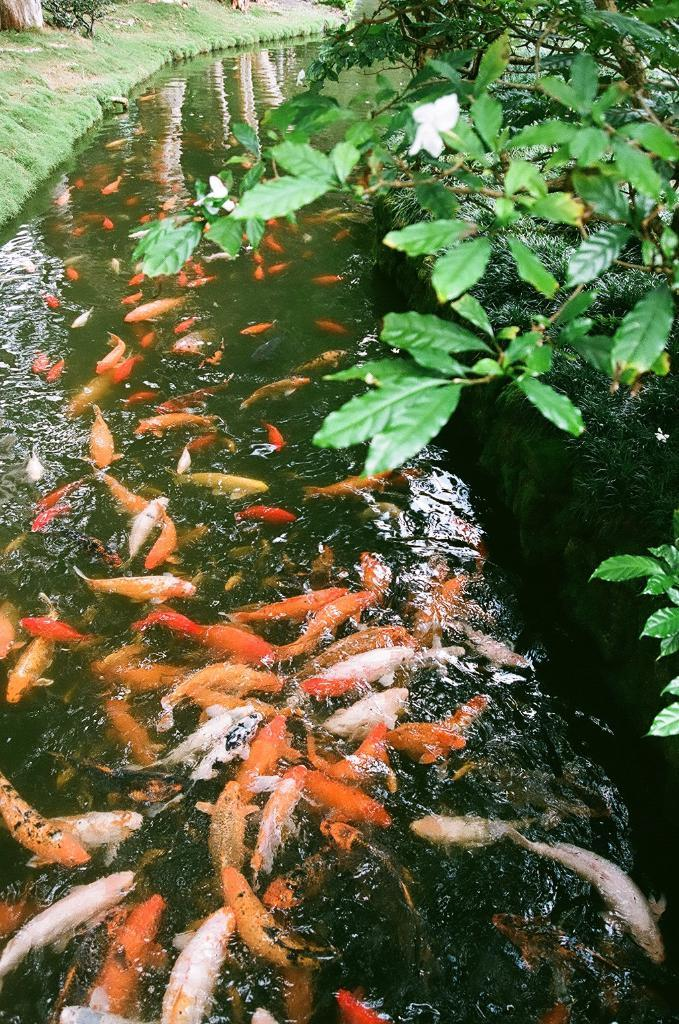What type of living organism can be seen in the image? There is a plant in the image. What can be found in the water in the image? There are many fishes in the water. What type of terrain is visible at the left side of the image? There is a grassy land at the left side of the image. What shape is the ant making on the earth in the image? There is no ant present in the image, so it is not possible to determine the shape it might be making on the earth. 